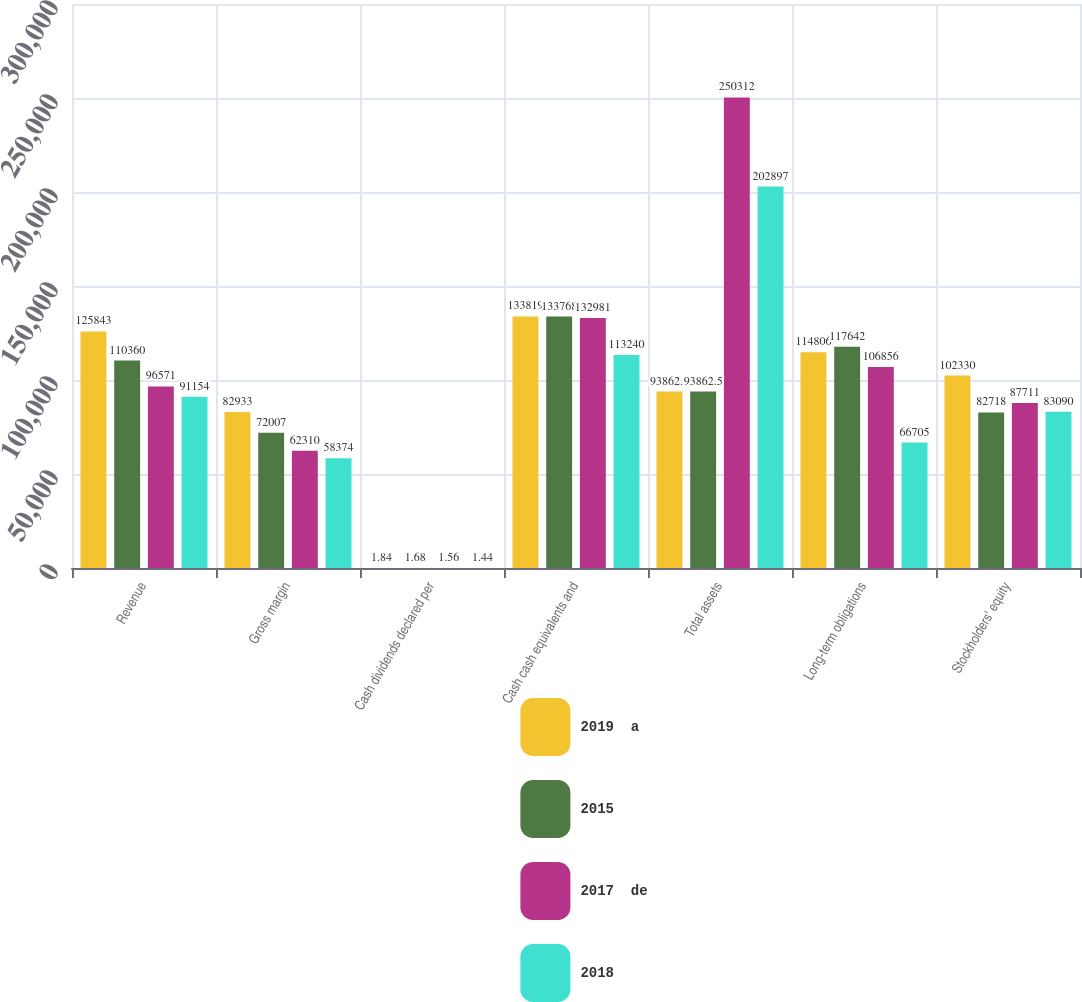Convert chart. <chart><loc_0><loc_0><loc_500><loc_500><stacked_bar_chart><ecel><fcel>Revenue<fcel>Gross margin<fcel>Cash dividends declared per<fcel>Cash cash equivalents and<fcel>Total assets<fcel>Long-term obligations<fcel>Stockholders' equity<nl><fcel>2019  a<fcel>125843<fcel>82933<fcel>1.84<fcel>133819<fcel>93862.5<fcel>114806<fcel>102330<nl><fcel>2015<fcel>110360<fcel>72007<fcel>1.68<fcel>133768<fcel>93862.5<fcel>117642<fcel>82718<nl><fcel>2017  de<fcel>96571<fcel>62310<fcel>1.56<fcel>132981<fcel>250312<fcel>106856<fcel>87711<nl><fcel>2018<fcel>91154<fcel>58374<fcel>1.44<fcel>113240<fcel>202897<fcel>66705<fcel>83090<nl></chart> 